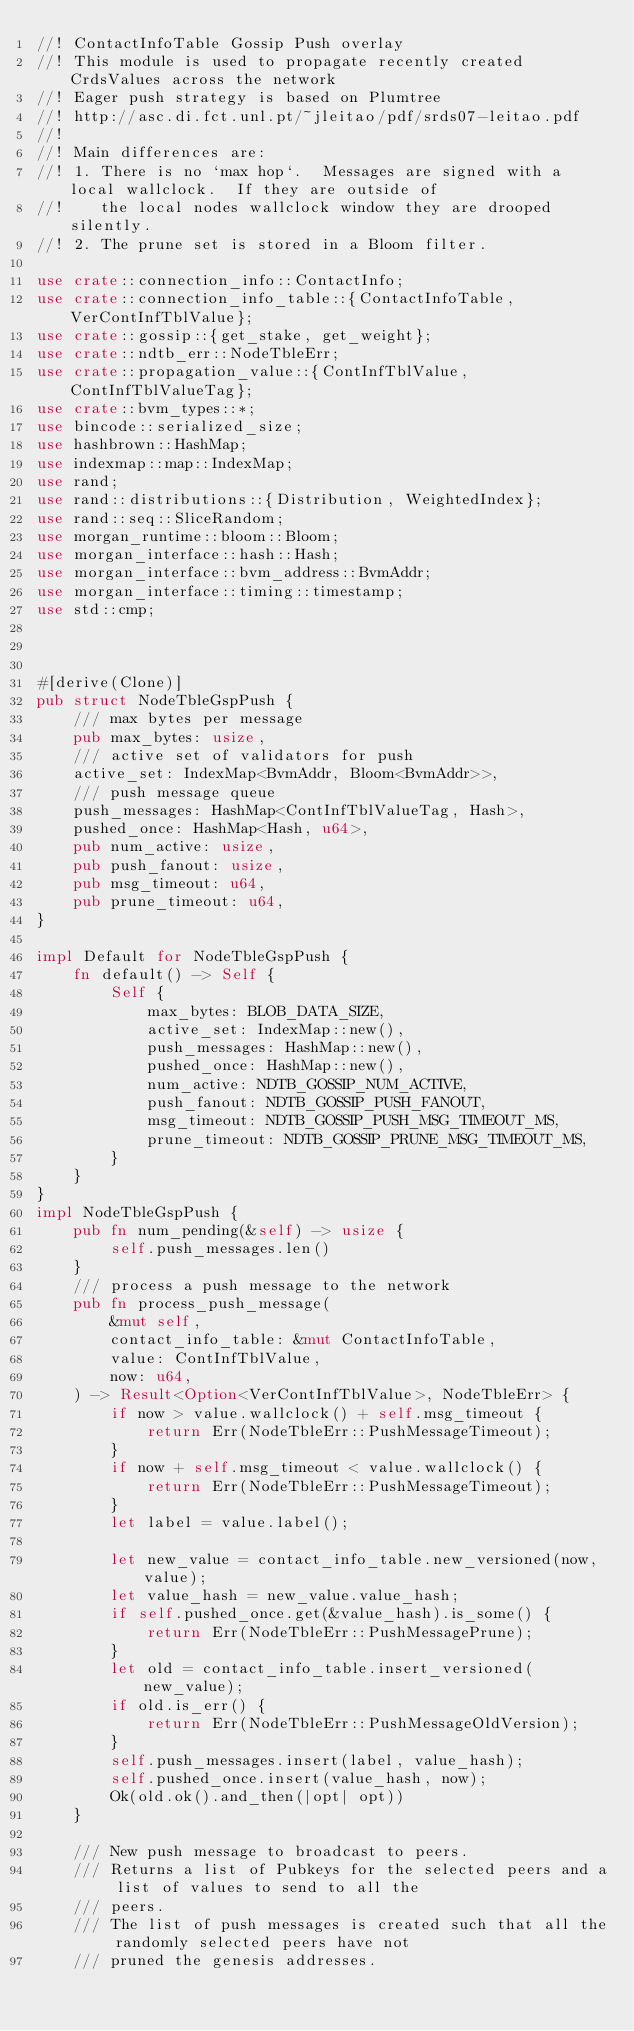<code> <loc_0><loc_0><loc_500><loc_500><_Rust_>//! ContactInfoTable Gossip Push overlay
//! This module is used to propagate recently created CrdsValues across the network
//! Eager push strategy is based on Plumtree
//! http://asc.di.fct.unl.pt/~jleitao/pdf/srds07-leitao.pdf
//!
//! Main differences are:
//! 1. There is no `max hop`.  Messages are signed with a local wallclock.  If they are outside of
//!    the local nodes wallclock window they are drooped silently.
//! 2. The prune set is stored in a Bloom filter.

use crate::connection_info::ContactInfo;
use crate::connection_info_table::{ContactInfoTable, VerContInfTblValue};
use crate::gossip::{get_stake, get_weight};
use crate::ndtb_err::NodeTbleErr;
use crate::propagation_value::{ContInfTblValue, ContInfTblValueTag};
use crate::bvm_types::*;
use bincode::serialized_size;
use hashbrown::HashMap;
use indexmap::map::IndexMap;
use rand;
use rand::distributions::{Distribution, WeightedIndex};
use rand::seq::SliceRandom;
use morgan_runtime::bloom::Bloom;
use morgan_interface::hash::Hash;
use morgan_interface::bvm_address::BvmAddr;
use morgan_interface::timing::timestamp;
use std::cmp;



#[derive(Clone)]
pub struct NodeTbleGspPush {
    /// max bytes per message
    pub max_bytes: usize,
    /// active set of validators for push
    active_set: IndexMap<BvmAddr, Bloom<BvmAddr>>,
    /// push message queue
    push_messages: HashMap<ContInfTblValueTag, Hash>,
    pushed_once: HashMap<Hash, u64>,
    pub num_active: usize,
    pub push_fanout: usize,
    pub msg_timeout: u64,
    pub prune_timeout: u64,
}

impl Default for NodeTbleGspPush {
    fn default() -> Self {
        Self {
            max_bytes: BLOB_DATA_SIZE,
            active_set: IndexMap::new(),
            push_messages: HashMap::new(),
            pushed_once: HashMap::new(),
            num_active: NDTB_GOSSIP_NUM_ACTIVE,
            push_fanout: NDTB_GOSSIP_PUSH_FANOUT,
            msg_timeout: NDTB_GOSSIP_PUSH_MSG_TIMEOUT_MS,
            prune_timeout: NDTB_GOSSIP_PRUNE_MSG_TIMEOUT_MS,
        }
    }
}
impl NodeTbleGspPush {
    pub fn num_pending(&self) -> usize {
        self.push_messages.len()
    }
    /// process a push message to the network
    pub fn process_push_message(
        &mut self,
        contact_info_table: &mut ContactInfoTable,
        value: ContInfTblValue,
        now: u64,
    ) -> Result<Option<VerContInfTblValue>, NodeTbleErr> {
        if now > value.wallclock() + self.msg_timeout {
            return Err(NodeTbleErr::PushMessageTimeout);
        }
        if now + self.msg_timeout < value.wallclock() {
            return Err(NodeTbleErr::PushMessageTimeout);
        }
        let label = value.label();

        let new_value = contact_info_table.new_versioned(now, value);
        let value_hash = new_value.value_hash;
        if self.pushed_once.get(&value_hash).is_some() {
            return Err(NodeTbleErr::PushMessagePrune);
        }
        let old = contact_info_table.insert_versioned(new_value);
        if old.is_err() {
            return Err(NodeTbleErr::PushMessageOldVersion);
        }
        self.push_messages.insert(label, value_hash);
        self.pushed_once.insert(value_hash, now);
        Ok(old.ok().and_then(|opt| opt))
    }

    /// New push message to broadcast to peers.
    /// Returns a list of Pubkeys for the selected peers and a list of values to send to all the
    /// peers.
    /// The list of push messages is created such that all the randomly selected peers have not
    /// pruned the genesis addresses.</code> 